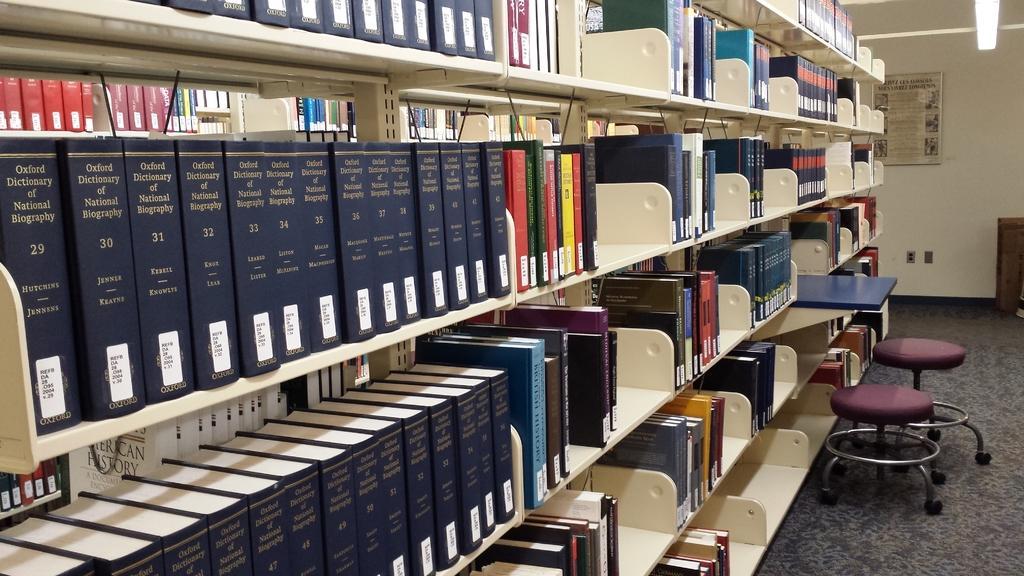Describe this image in one or two sentences. In this picture we can see few books in the racks, on the right side of the image we can find few chairs, in the background we can see a poster on the wall, and also we can see a light. 